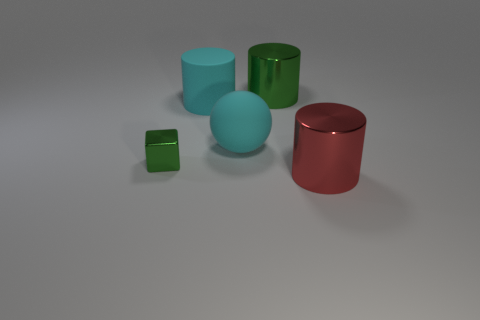Do the cyan matte object that is to the left of the large cyan matte sphere and the tiny green thing have the same shape?
Your answer should be very brief. No. The large thing that is made of the same material as the large sphere is what color?
Offer a terse response. Cyan. What number of tiny objects have the same material as the big cyan cylinder?
Your response must be concise. 0. What is the color of the big shiny thing that is on the left side of the metallic cylinder in front of the shiny cylinder that is behind the tiny green metal thing?
Ensure brevity in your answer.  Green. Do the sphere and the green cylinder have the same size?
Your response must be concise. Yes. Is there anything else that is the same shape as the small thing?
Your answer should be compact. No. How many things are metallic things that are left of the large red thing or large cyan rubber things?
Provide a short and direct response. 4. Is the shape of the big red metallic object the same as the big green object?
Provide a short and direct response. Yes. How many other things are there of the same size as the cyan matte cylinder?
Provide a short and direct response. 3. What color is the matte cylinder?
Your response must be concise. Cyan. 